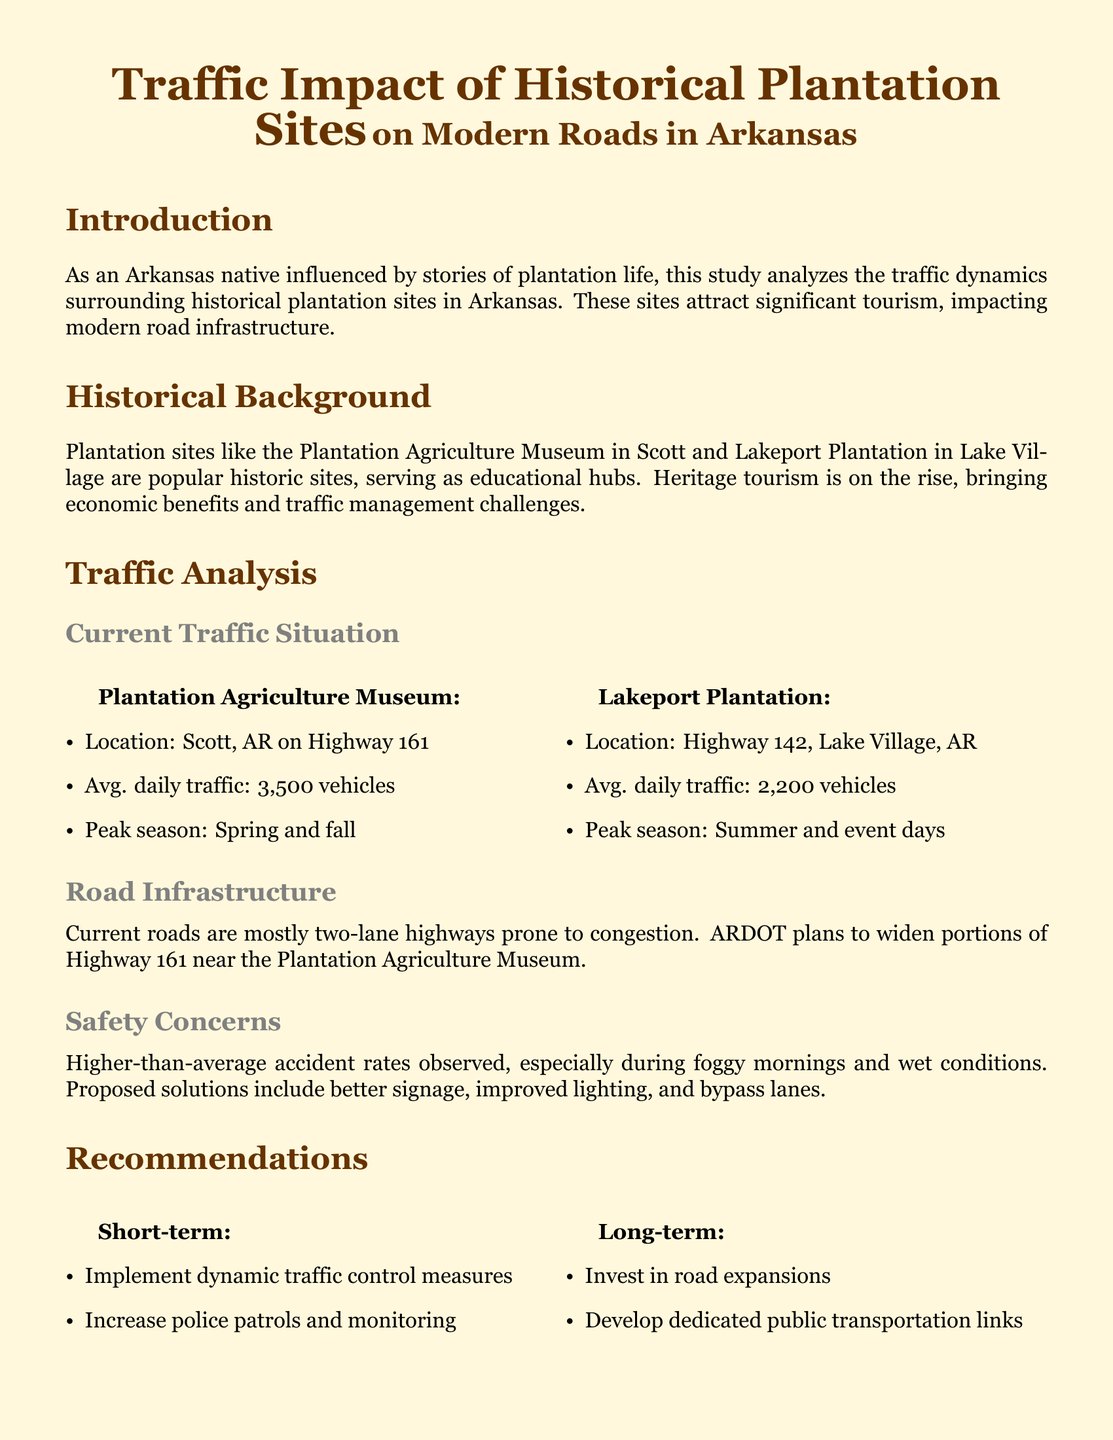What is the average daily traffic at the Plantation Agriculture Museum? The average daily traffic at the Plantation Agriculture Museum is explicitly listed in the document, which states it is 3,500 vehicles.
Answer: 3,500 vehicles What is the peak season for Lakeport Plantation? The document specifies that the peak season for Lakeport Plantation occurs in the summer and on event days.
Answer: Summer and event days What type of roads are most common near the plantation sites? The document mentions that the current roads are mostly two-lane highways, which describes their structure.
Answer: Two-lane highways What are two proposed short-term recommendations? The document outlines recommendations, two of which are implementing dynamic traffic control measures and increasing police patrols, detailing immediate strategies for traffic management.
Answer: Dynamic traffic control measures, police patrols What safety concern is highlighted regarding traffic? The document identifies higher-than-average accident rates as a primary safety concern, indicating a significant issue that needs to be addressed.
Answer: Higher-than-average accident rates Which plantation site is located in Scott, AR? The document clearly names the Plantation Agriculture Museum as the site located in Scott, AR, providing specific location information.
Answer: Plantation Agriculture Museum What long-term investment does the document recommend? The recommendations section details that investing in road expansions is one of the long-term strategies advised to manage traffic flow around plantation sites.
Answer: Road expansions What does ARDOT stand for? The document refers to ARDOT in the context of road planning, which stands for the Arkansas Department of Transportation, establishing its role in infrastructure management.
Answer: Arkansas Department of Transportation 